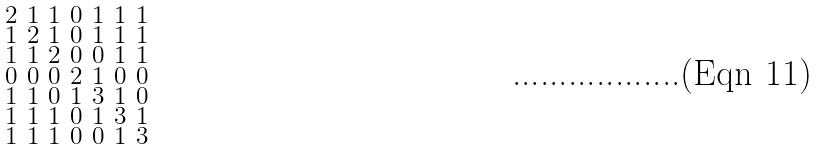Convert formula to latex. <formula><loc_0><loc_0><loc_500><loc_500>\begin{smallmatrix} 2 & 1 & 1 & 0 & 1 & 1 & 1 \\ 1 & 2 & 1 & 0 & 1 & 1 & 1 \\ 1 & 1 & 2 & 0 & 0 & 1 & 1 \\ 0 & 0 & 0 & 2 & 1 & 0 & 0 \\ 1 & 1 & 0 & 1 & 3 & 1 & 0 \\ 1 & 1 & 1 & 0 & 1 & 3 & 1 \\ 1 & 1 & 1 & 0 & 0 & 1 & 3 \end{smallmatrix}</formula> 